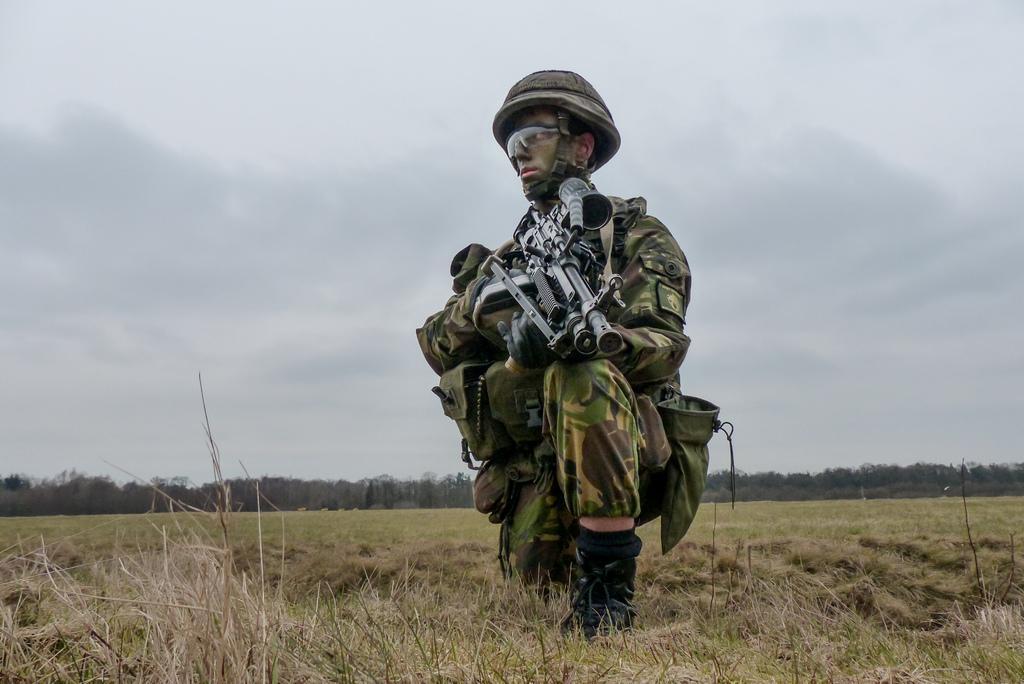Please provide a concise description of this image. There is a person on a greenery ground and wearing military dress and holding a gun on his hand and there are trees in the background. 